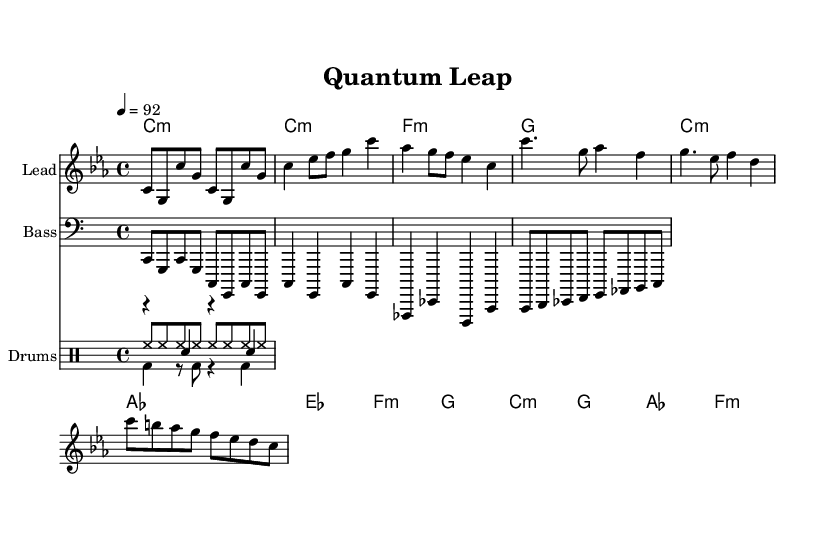What is the key signature of this music? The key signature is C minor, which has three flats (B♭, E♭, and A♭). This can be determined by looking at the key signature indicated at the beginning of the staff.
Answer: C minor What is the time signature of this music? The time signature is 4/4, indicated at the beginning of the piece. This means there are four beats in each measure, and the quarter note gets one beat.
Answer: 4/4 What is the tempo marking of this music? The tempo marking is quarter note equals 92, which describes the speed of the music. This information is given at the start of the piece, indicating how fast each quarter note should be played.
Answer: 92 How many measures are there in the verse section? The verse section consists of four measures. This can be counted by examining the distinct groupings of music notes and time signatures in the verse portion.
Answer: 4 What is the main chord used in the chorus? The main chord used in the chorus is A♭ major. By analyzing the chord progressions in the chorus section, this chord is prominently featured.
Answer: A♭ What instruments are represented in this sheet music? The instruments represented are Lead, Bass, and Drums. This is indicated at the start of each staff, where "Lead," "Bass," and "Drums" are labeled respectively.
Answer: Lead, Bass, Drums Which section of the rap features a transition in melody? The bridge section features a transition in melody. This is identifiable by the different set of notes and rhythm that contrasts with the verse and chorus sections.
Answer: Bridge 